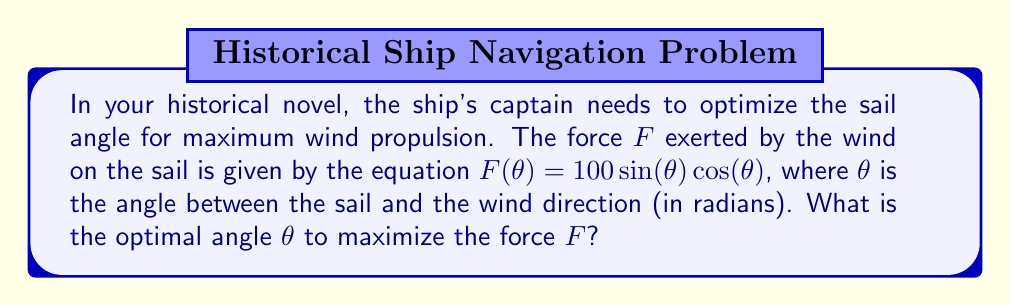Show me your answer to this math problem. To find the optimal angle that maximizes the force, we need to find the maximum of the function $F(\theta) = 100 \sin(\theta) \cos(\theta)$. We can do this by following these steps:

1) First, let's simplify the function using the trigonometric identity $\sin(2\theta) = 2\sin(\theta)\cos(\theta)$:

   $F(\theta) = 100 \sin(\theta) \cos(\theta) = 50 \sin(2\theta)$

2) To find the maximum, we need to find where the derivative of $F(\theta)$ equals zero:

   $F'(\theta) = 50 \cdot 2 \cos(2\theta) = 100 \cos(2\theta)$

3) Set the derivative to zero and solve:

   $100 \cos(2\theta) = 0$
   $\cos(2\theta) = 0$

4) The cosine function is zero when its argument is $\frac{\pi}{2}$ or $\frac{3\pi}{2}$:

   $2\theta = \frac{\pi}{2}$ or $2\theta = \frac{3\pi}{2}$

5) Solving for $\theta$:

   $\theta = \frac{\pi}{4}$ or $\theta = \frac{3\pi}{4}$

6) To determine which of these is the maximum (rather than the minimum), we can check the second derivative:

   $F''(\theta) = -200 \sin(2\theta)$

   At $\theta = \frac{\pi}{4}$, $F''(\frac{\pi}{4}) = -200 \sin(\frac{\pi}{2}) = -200 < 0$, indicating a maximum.
   At $\theta = \frac{3\pi}{4}$, $F''(\frac{3\pi}{4}) = -200 \sin(\frac{3\pi}{2}) = 200 > 0$, indicating a minimum.

Therefore, the optimal angle to maximize the force is $\frac{\pi}{4}$ radians, or 45 degrees.
Answer: $\frac{\pi}{4}$ radians (45°) 